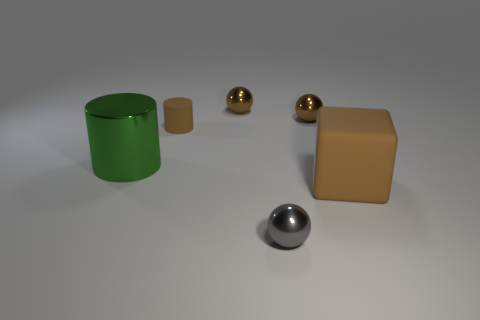There is a cylinder that is behind the green cylinder; does it have the same color as the big matte thing?
Offer a terse response. Yes. Is there a big brown object that has the same material as the tiny cylinder?
Your answer should be compact. Yes. How many blue objects are tiny balls or metallic cylinders?
Give a very brief answer. 0. Are there more large green objects that are behind the green object than big blue rubber cubes?
Your response must be concise. No. Is the brown cube the same size as the gray metal sphere?
Keep it short and to the point. No. The big cube that is the same material as the tiny cylinder is what color?
Give a very brief answer. Brown. What is the shape of the matte thing that is the same color as the matte cylinder?
Offer a terse response. Cube. Are there an equal number of green objects behind the small rubber object and tiny metallic spheres behind the big block?
Ensure brevity in your answer.  No. There is a large object that is in front of the big thing that is to the left of the brown cube; what is its shape?
Offer a very short reply. Cube. What material is the tiny brown thing that is the same shape as the green thing?
Ensure brevity in your answer.  Rubber. 